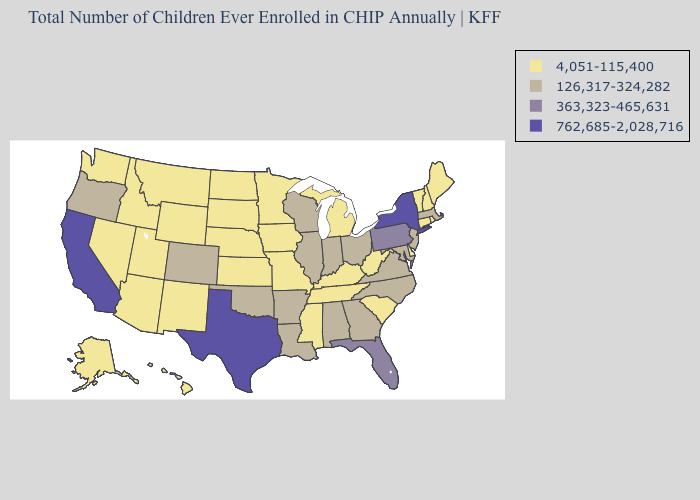What is the value of Washington?
Concise answer only. 4,051-115,400. Does North Carolina have the highest value in the South?
Be succinct. No. What is the value of Louisiana?
Give a very brief answer. 126,317-324,282. Name the states that have a value in the range 762,685-2,028,716?
Answer briefly. California, New York, Texas. Is the legend a continuous bar?
Concise answer only. No. Does Oregon have the lowest value in the USA?
Give a very brief answer. No. What is the value of Pennsylvania?
Short answer required. 363,323-465,631. Name the states that have a value in the range 126,317-324,282?
Keep it brief. Alabama, Arkansas, Colorado, Georgia, Illinois, Indiana, Louisiana, Maryland, Massachusetts, New Jersey, North Carolina, Ohio, Oklahoma, Oregon, Virginia, Wisconsin. Name the states that have a value in the range 762,685-2,028,716?
Quick response, please. California, New York, Texas. Which states hav the highest value in the West?
Answer briefly. California. Does New Mexico have the lowest value in the USA?
Keep it brief. Yes. What is the highest value in states that border Texas?
Write a very short answer. 126,317-324,282. What is the value of Mississippi?
Write a very short answer. 4,051-115,400. Among the states that border California , does Nevada have the lowest value?
Give a very brief answer. Yes. Name the states that have a value in the range 126,317-324,282?
Concise answer only. Alabama, Arkansas, Colorado, Georgia, Illinois, Indiana, Louisiana, Maryland, Massachusetts, New Jersey, North Carolina, Ohio, Oklahoma, Oregon, Virginia, Wisconsin. 